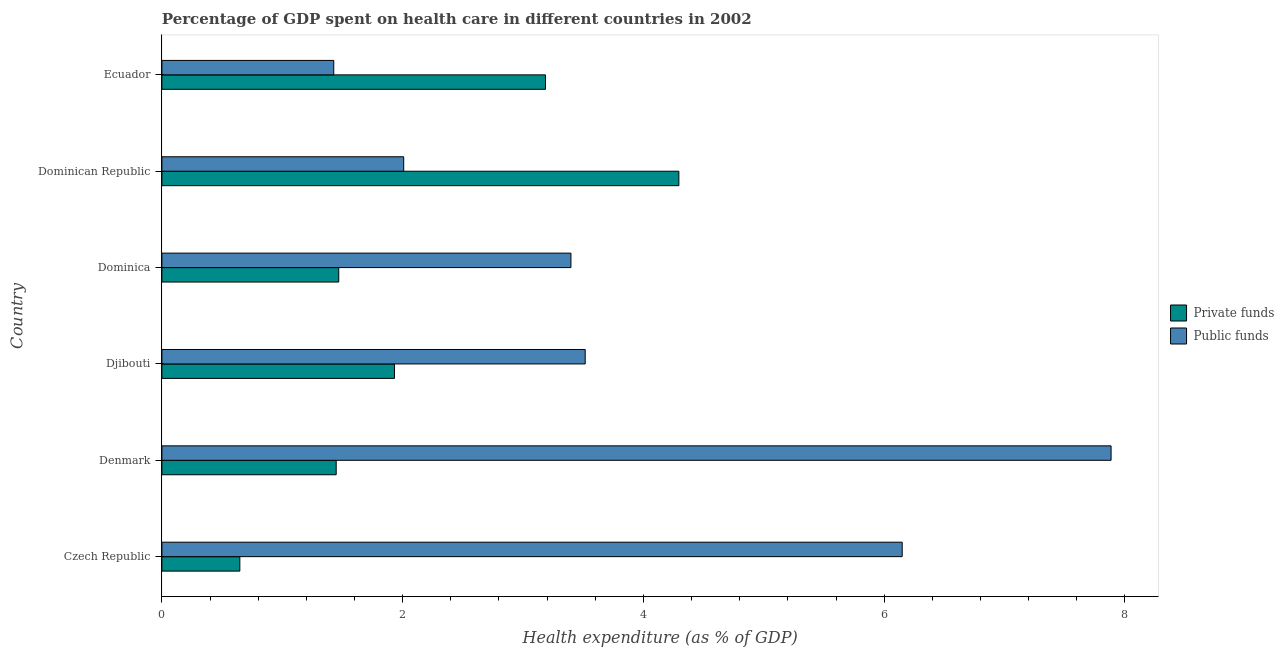How many different coloured bars are there?
Provide a succinct answer. 2. How many groups of bars are there?
Give a very brief answer. 6. Are the number of bars per tick equal to the number of legend labels?
Your answer should be very brief. Yes. What is the label of the 6th group of bars from the top?
Offer a very short reply. Czech Republic. What is the amount of public funds spent in healthcare in Denmark?
Keep it short and to the point. 7.89. Across all countries, what is the maximum amount of private funds spent in healthcare?
Your answer should be very brief. 4.29. Across all countries, what is the minimum amount of public funds spent in healthcare?
Your answer should be compact. 1.43. In which country was the amount of private funds spent in healthcare maximum?
Offer a very short reply. Dominican Republic. In which country was the amount of private funds spent in healthcare minimum?
Your answer should be compact. Czech Republic. What is the total amount of private funds spent in healthcare in the graph?
Provide a short and direct response. 12.98. What is the difference between the amount of public funds spent in healthcare in Dominica and that in Dominican Republic?
Provide a succinct answer. 1.39. What is the difference between the amount of public funds spent in healthcare in Dominican Republic and the amount of private funds spent in healthcare in Denmark?
Offer a very short reply. 0.56. What is the average amount of public funds spent in healthcare per country?
Keep it short and to the point. 4.06. What is the difference between the amount of private funds spent in healthcare and amount of public funds spent in healthcare in Denmark?
Your response must be concise. -6.44. In how many countries, is the amount of public funds spent in healthcare greater than 5.6 %?
Ensure brevity in your answer.  2. What is the ratio of the amount of public funds spent in healthcare in Czech Republic to that in Djibouti?
Your answer should be compact. 1.75. What is the difference between the highest and the second highest amount of public funds spent in healthcare?
Provide a succinct answer. 1.74. What is the difference between the highest and the lowest amount of private funds spent in healthcare?
Keep it short and to the point. 3.65. In how many countries, is the amount of private funds spent in healthcare greater than the average amount of private funds spent in healthcare taken over all countries?
Provide a short and direct response. 2. What does the 2nd bar from the top in Dominica represents?
Keep it short and to the point. Private funds. What does the 1st bar from the bottom in Czech Republic represents?
Offer a very short reply. Private funds. How many bars are there?
Provide a succinct answer. 12. Are all the bars in the graph horizontal?
Provide a short and direct response. Yes. What is the difference between two consecutive major ticks on the X-axis?
Give a very brief answer. 2. Does the graph contain any zero values?
Keep it short and to the point. No. How many legend labels are there?
Your answer should be compact. 2. What is the title of the graph?
Your response must be concise. Percentage of GDP spent on health care in different countries in 2002. What is the label or title of the X-axis?
Your answer should be compact. Health expenditure (as % of GDP). What is the Health expenditure (as % of GDP) of Private funds in Czech Republic?
Provide a succinct answer. 0.65. What is the Health expenditure (as % of GDP) of Public funds in Czech Republic?
Give a very brief answer. 6.15. What is the Health expenditure (as % of GDP) in Private funds in Denmark?
Your answer should be compact. 1.45. What is the Health expenditure (as % of GDP) in Public funds in Denmark?
Your answer should be compact. 7.89. What is the Health expenditure (as % of GDP) in Private funds in Djibouti?
Make the answer very short. 1.93. What is the Health expenditure (as % of GDP) in Public funds in Djibouti?
Offer a very short reply. 3.52. What is the Health expenditure (as % of GDP) in Private funds in Dominica?
Offer a very short reply. 1.47. What is the Health expenditure (as % of GDP) of Public funds in Dominica?
Give a very brief answer. 3.4. What is the Health expenditure (as % of GDP) of Private funds in Dominican Republic?
Your response must be concise. 4.29. What is the Health expenditure (as % of GDP) in Public funds in Dominican Republic?
Provide a short and direct response. 2.01. What is the Health expenditure (as % of GDP) in Private funds in Ecuador?
Offer a very short reply. 3.19. What is the Health expenditure (as % of GDP) of Public funds in Ecuador?
Make the answer very short. 1.43. Across all countries, what is the maximum Health expenditure (as % of GDP) in Private funds?
Give a very brief answer. 4.29. Across all countries, what is the maximum Health expenditure (as % of GDP) of Public funds?
Your response must be concise. 7.89. Across all countries, what is the minimum Health expenditure (as % of GDP) of Private funds?
Provide a succinct answer. 0.65. Across all countries, what is the minimum Health expenditure (as % of GDP) in Public funds?
Your answer should be very brief. 1.43. What is the total Health expenditure (as % of GDP) in Private funds in the graph?
Your answer should be compact. 12.98. What is the total Health expenditure (as % of GDP) of Public funds in the graph?
Give a very brief answer. 24.39. What is the difference between the Health expenditure (as % of GDP) in Private funds in Czech Republic and that in Denmark?
Make the answer very short. -0.8. What is the difference between the Health expenditure (as % of GDP) of Public funds in Czech Republic and that in Denmark?
Ensure brevity in your answer.  -1.74. What is the difference between the Health expenditure (as % of GDP) of Private funds in Czech Republic and that in Djibouti?
Provide a short and direct response. -1.28. What is the difference between the Health expenditure (as % of GDP) in Public funds in Czech Republic and that in Djibouti?
Your answer should be compact. 2.63. What is the difference between the Health expenditure (as % of GDP) of Private funds in Czech Republic and that in Dominica?
Your answer should be very brief. -0.82. What is the difference between the Health expenditure (as % of GDP) of Public funds in Czech Republic and that in Dominica?
Your answer should be compact. 2.75. What is the difference between the Health expenditure (as % of GDP) in Private funds in Czech Republic and that in Dominican Republic?
Provide a succinct answer. -3.65. What is the difference between the Health expenditure (as % of GDP) of Public funds in Czech Republic and that in Dominican Republic?
Ensure brevity in your answer.  4.14. What is the difference between the Health expenditure (as % of GDP) in Private funds in Czech Republic and that in Ecuador?
Provide a short and direct response. -2.54. What is the difference between the Health expenditure (as % of GDP) in Public funds in Czech Republic and that in Ecuador?
Offer a terse response. 4.72. What is the difference between the Health expenditure (as % of GDP) of Private funds in Denmark and that in Djibouti?
Give a very brief answer. -0.48. What is the difference between the Health expenditure (as % of GDP) in Public funds in Denmark and that in Djibouti?
Provide a succinct answer. 4.37. What is the difference between the Health expenditure (as % of GDP) of Private funds in Denmark and that in Dominica?
Provide a short and direct response. -0.02. What is the difference between the Health expenditure (as % of GDP) in Public funds in Denmark and that in Dominica?
Provide a succinct answer. 4.49. What is the difference between the Health expenditure (as % of GDP) of Private funds in Denmark and that in Dominican Republic?
Provide a succinct answer. -2.85. What is the difference between the Health expenditure (as % of GDP) of Public funds in Denmark and that in Dominican Republic?
Make the answer very short. 5.88. What is the difference between the Health expenditure (as % of GDP) of Private funds in Denmark and that in Ecuador?
Your answer should be compact. -1.74. What is the difference between the Health expenditure (as % of GDP) of Public funds in Denmark and that in Ecuador?
Provide a succinct answer. 6.46. What is the difference between the Health expenditure (as % of GDP) of Private funds in Djibouti and that in Dominica?
Your response must be concise. 0.46. What is the difference between the Health expenditure (as % of GDP) in Public funds in Djibouti and that in Dominica?
Make the answer very short. 0.12. What is the difference between the Health expenditure (as % of GDP) of Private funds in Djibouti and that in Dominican Republic?
Ensure brevity in your answer.  -2.36. What is the difference between the Health expenditure (as % of GDP) of Public funds in Djibouti and that in Dominican Republic?
Ensure brevity in your answer.  1.51. What is the difference between the Health expenditure (as % of GDP) in Private funds in Djibouti and that in Ecuador?
Your answer should be compact. -1.25. What is the difference between the Health expenditure (as % of GDP) of Public funds in Djibouti and that in Ecuador?
Offer a terse response. 2.09. What is the difference between the Health expenditure (as % of GDP) of Private funds in Dominica and that in Dominican Republic?
Offer a very short reply. -2.83. What is the difference between the Health expenditure (as % of GDP) in Public funds in Dominica and that in Dominican Republic?
Provide a succinct answer. 1.39. What is the difference between the Health expenditure (as % of GDP) of Private funds in Dominica and that in Ecuador?
Ensure brevity in your answer.  -1.72. What is the difference between the Health expenditure (as % of GDP) in Public funds in Dominica and that in Ecuador?
Your answer should be compact. 1.97. What is the difference between the Health expenditure (as % of GDP) in Private funds in Dominican Republic and that in Ecuador?
Your response must be concise. 1.11. What is the difference between the Health expenditure (as % of GDP) in Public funds in Dominican Republic and that in Ecuador?
Offer a very short reply. 0.58. What is the difference between the Health expenditure (as % of GDP) of Private funds in Czech Republic and the Health expenditure (as % of GDP) of Public funds in Denmark?
Ensure brevity in your answer.  -7.24. What is the difference between the Health expenditure (as % of GDP) of Private funds in Czech Republic and the Health expenditure (as % of GDP) of Public funds in Djibouti?
Make the answer very short. -2.87. What is the difference between the Health expenditure (as % of GDP) in Private funds in Czech Republic and the Health expenditure (as % of GDP) in Public funds in Dominica?
Make the answer very short. -2.75. What is the difference between the Health expenditure (as % of GDP) of Private funds in Czech Republic and the Health expenditure (as % of GDP) of Public funds in Dominican Republic?
Make the answer very short. -1.36. What is the difference between the Health expenditure (as % of GDP) in Private funds in Czech Republic and the Health expenditure (as % of GDP) in Public funds in Ecuador?
Provide a succinct answer. -0.78. What is the difference between the Health expenditure (as % of GDP) in Private funds in Denmark and the Health expenditure (as % of GDP) in Public funds in Djibouti?
Keep it short and to the point. -2.07. What is the difference between the Health expenditure (as % of GDP) in Private funds in Denmark and the Health expenditure (as % of GDP) in Public funds in Dominica?
Your answer should be compact. -1.95. What is the difference between the Health expenditure (as % of GDP) in Private funds in Denmark and the Health expenditure (as % of GDP) in Public funds in Dominican Republic?
Your response must be concise. -0.56. What is the difference between the Health expenditure (as % of GDP) in Private funds in Denmark and the Health expenditure (as % of GDP) in Public funds in Ecuador?
Give a very brief answer. 0.02. What is the difference between the Health expenditure (as % of GDP) in Private funds in Djibouti and the Health expenditure (as % of GDP) in Public funds in Dominica?
Your answer should be very brief. -1.47. What is the difference between the Health expenditure (as % of GDP) in Private funds in Djibouti and the Health expenditure (as % of GDP) in Public funds in Dominican Republic?
Your answer should be compact. -0.08. What is the difference between the Health expenditure (as % of GDP) in Private funds in Djibouti and the Health expenditure (as % of GDP) in Public funds in Ecuador?
Keep it short and to the point. 0.5. What is the difference between the Health expenditure (as % of GDP) in Private funds in Dominica and the Health expenditure (as % of GDP) in Public funds in Dominican Republic?
Offer a terse response. -0.54. What is the difference between the Health expenditure (as % of GDP) of Private funds in Dominica and the Health expenditure (as % of GDP) of Public funds in Ecuador?
Your response must be concise. 0.04. What is the difference between the Health expenditure (as % of GDP) of Private funds in Dominican Republic and the Health expenditure (as % of GDP) of Public funds in Ecuador?
Your answer should be very brief. 2.87. What is the average Health expenditure (as % of GDP) in Private funds per country?
Your answer should be very brief. 2.16. What is the average Health expenditure (as % of GDP) of Public funds per country?
Provide a succinct answer. 4.06. What is the difference between the Health expenditure (as % of GDP) in Private funds and Health expenditure (as % of GDP) in Public funds in Czech Republic?
Offer a terse response. -5.5. What is the difference between the Health expenditure (as % of GDP) of Private funds and Health expenditure (as % of GDP) of Public funds in Denmark?
Offer a very short reply. -6.44. What is the difference between the Health expenditure (as % of GDP) in Private funds and Health expenditure (as % of GDP) in Public funds in Djibouti?
Give a very brief answer. -1.58. What is the difference between the Health expenditure (as % of GDP) of Private funds and Health expenditure (as % of GDP) of Public funds in Dominica?
Your answer should be very brief. -1.93. What is the difference between the Health expenditure (as % of GDP) of Private funds and Health expenditure (as % of GDP) of Public funds in Dominican Republic?
Offer a terse response. 2.29. What is the difference between the Health expenditure (as % of GDP) in Private funds and Health expenditure (as % of GDP) in Public funds in Ecuador?
Offer a very short reply. 1.76. What is the ratio of the Health expenditure (as % of GDP) of Private funds in Czech Republic to that in Denmark?
Offer a terse response. 0.45. What is the ratio of the Health expenditure (as % of GDP) of Public funds in Czech Republic to that in Denmark?
Your answer should be very brief. 0.78. What is the ratio of the Health expenditure (as % of GDP) of Private funds in Czech Republic to that in Djibouti?
Give a very brief answer. 0.34. What is the ratio of the Health expenditure (as % of GDP) in Public funds in Czech Republic to that in Djibouti?
Your response must be concise. 1.75. What is the ratio of the Health expenditure (as % of GDP) of Private funds in Czech Republic to that in Dominica?
Provide a succinct answer. 0.44. What is the ratio of the Health expenditure (as % of GDP) in Public funds in Czech Republic to that in Dominica?
Your response must be concise. 1.81. What is the ratio of the Health expenditure (as % of GDP) of Private funds in Czech Republic to that in Dominican Republic?
Provide a succinct answer. 0.15. What is the ratio of the Health expenditure (as % of GDP) in Public funds in Czech Republic to that in Dominican Republic?
Provide a short and direct response. 3.06. What is the ratio of the Health expenditure (as % of GDP) in Private funds in Czech Republic to that in Ecuador?
Give a very brief answer. 0.2. What is the ratio of the Health expenditure (as % of GDP) of Public funds in Czech Republic to that in Ecuador?
Offer a terse response. 4.31. What is the ratio of the Health expenditure (as % of GDP) in Private funds in Denmark to that in Djibouti?
Offer a terse response. 0.75. What is the ratio of the Health expenditure (as % of GDP) in Public funds in Denmark to that in Djibouti?
Make the answer very short. 2.24. What is the ratio of the Health expenditure (as % of GDP) of Private funds in Denmark to that in Dominica?
Offer a terse response. 0.99. What is the ratio of the Health expenditure (as % of GDP) in Public funds in Denmark to that in Dominica?
Ensure brevity in your answer.  2.32. What is the ratio of the Health expenditure (as % of GDP) in Private funds in Denmark to that in Dominican Republic?
Make the answer very short. 0.34. What is the ratio of the Health expenditure (as % of GDP) in Public funds in Denmark to that in Dominican Republic?
Provide a succinct answer. 3.93. What is the ratio of the Health expenditure (as % of GDP) of Private funds in Denmark to that in Ecuador?
Keep it short and to the point. 0.45. What is the ratio of the Health expenditure (as % of GDP) of Public funds in Denmark to that in Ecuador?
Make the answer very short. 5.52. What is the ratio of the Health expenditure (as % of GDP) in Private funds in Djibouti to that in Dominica?
Your answer should be very brief. 1.32. What is the ratio of the Health expenditure (as % of GDP) of Public funds in Djibouti to that in Dominica?
Ensure brevity in your answer.  1.03. What is the ratio of the Health expenditure (as % of GDP) in Private funds in Djibouti to that in Dominican Republic?
Keep it short and to the point. 0.45. What is the ratio of the Health expenditure (as % of GDP) of Public funds in Djibouti to that in Dominican Republic?
Keep it short and to the point. 1.75. What is the ratio of the Health expenditure (as % of GDP) of Private funds in Djibouti to that in Ecuador?
Ensure brevity in your answer.  0.61. What is the ratio of the Health expenditure (as % of GDP) in Public funds in Djibouti to that in Ecuador?
Offer a very short reply. 2.46. What is the ratio of the Health expenditure (as % of GDP) in Private funds in Dominica to that in Dominican Republic?
Keep it short and to the point. 0.34. What is the ratio of the Health expenditure (as % of GDP) in Public funds in Dominica to that in Dominican Republic?
Your response must be concise. 1.69. What is the ratio of the Health expenditure (as % of GDP) in Private funds in Dominica to that in Ecuador?
Give a very brief answer. 0.46. What is the ratio of the Health expenditure (as % of GDP) in Public funds in Dominica to that in Ecuador?
Offer a very short reply. 2.38. What is the ratio of the Health expenditure (as % of GDP) in Private funds in Dominican Republic to that in Ecuador?
Offer a terse response. 1.35. What is the ratio of the Health expenditure (as % of GDP) in Public funds in Dominican Republic to that in Ecuador?
Provide a short and direct response. 1.41. What is the difference between the highest and the second highest Health expenditure (as % of GDP) of Private funds?
Your answer should be compact. 1.11. What is the difference between the highest and the second highest Health expenditure (as % of GDP) of Public funds?
Make the answer very short. 1.74. What is the difference between the highest and the lowest Health expenditure (as % of GDP) of Private funds?
Ensure brevity in your answer.  3.65. What is the difference between the highest and the lowest Health expenditure (as % of GDP) in Public funds?
Provide a short and direct response. 6.46. 